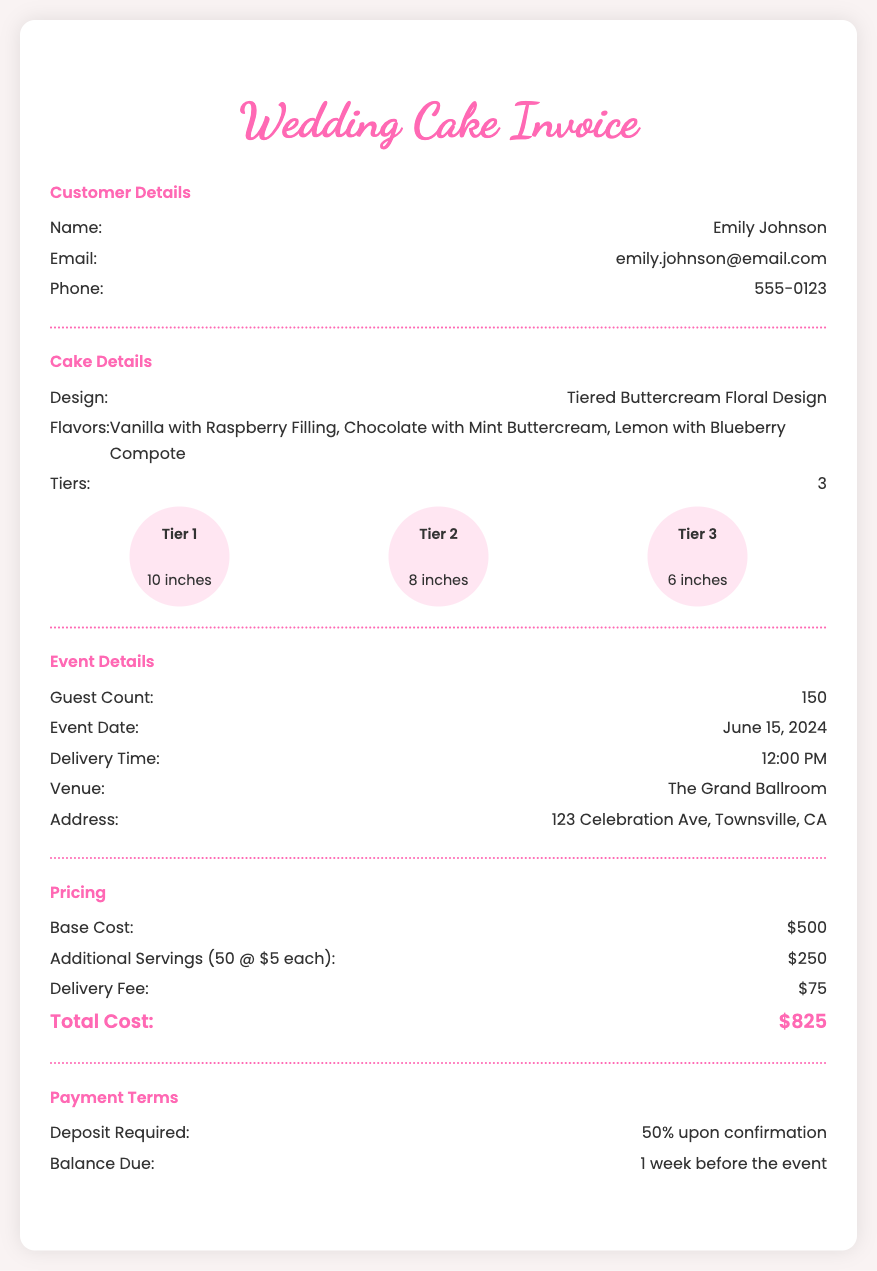What is the customer's name? The customer's name is mentioned in the document under "Customer Details."
Answer: Emily Johnson What is the total cost of the wedding cake? The total cost can be found in the "Pricing" section of the document.
Answer: $825 How many tiers does the cake have? The number of tiers is specified in the "Cake Details" section.
Answer: 3 What is the guest count for the event? The guest count is listed in the "Event Details" section.
Answer: 150 What is the delivery time for the cake? The delivery time is indicated in the "Event Details" section.
Answer: 12:00 PM What is the venue for the event? The venue is provided in the "Event Details" section.
Answer: The Grand Ballroom What flavors are included in the cake? The flavors of the cake are mentioned in the "Cake Details" section.
Answer: Vanilla with Raspberry Filling, Chocolate with Mint Buttercream, Lemon with Blueberry Compote When is the event date? The event date is provided in the "Event Details" section.
Answer: June 15, 2024 What is the deposit required for the cake? The deposit amount is specified in the "Payment Terms" section.
Answer: 50% upon confirmation 